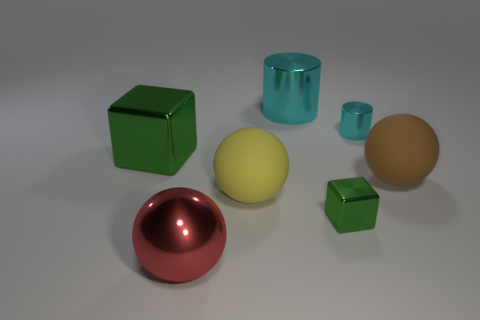The small cylinder has what color?
Provide a short and direct response. Cyan. Do the big thing right of the tiny cylinder and the large matte thing left of the large cylinder have the same shape?
Provide a succinct answer. Yes. There is a small thing that is in front of the small cyan metallic cylinder; what color is it?
Offer a terse response. Green. Are there fewer cylinders that are left of the red metallic sphere than matte balls to the left of the large green metal object?
Keep it short and to the point. No. What number of other objects are there of the same material as the small cyan object?
Provide a short and direct response. 4. Are the tiny cylinder and the yellow ball made of the same material?
Keep it short and to the point. No. What number of other things are there of the same size as the yellow matte sphere?
Keep it short and to the point. 4. What size is the shiny block that is on the right side of the cube that is behind the big brown object?
Provide a succinct answer. Small. There is a large rubber thing right of the large object behind the green object to the left of the metallic sphere; what is its color?
Your answer should be very brief. Brown. How big is the thing that is in front of the tiny cylinder and to the right of the tiny green object?
Provide a short and direct response. Large. 